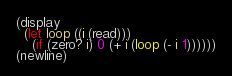<code> <loc_0><loc_0><loc_500><loc_500><_Scheme_>(display
  (let loop ((i (read)))
    (if (zero? i) 0 (+ i (loop (- i 1))))))
(newline)
</code> 